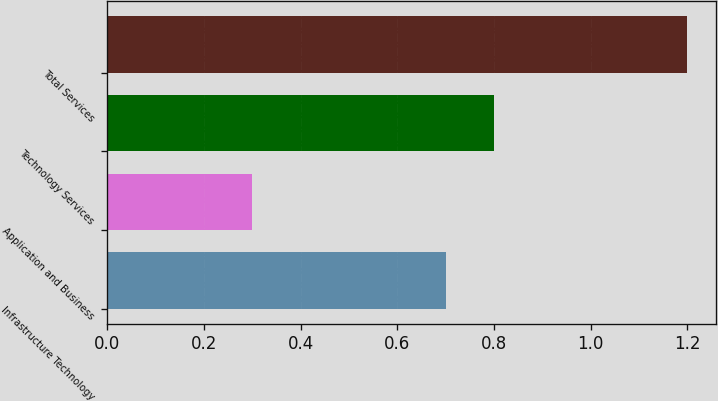Convert chart to OTSL. <chart><loc_0><loc_0><loc_500><loc_500><bar_chart><fcel>Infrastructure Technology<fcel>Application and Business<fcel>Technology Services<fcel>Total Services<nl><fcel>0.7<fcel>0.3<fcel>0.8<fcel>1.2<nl></chart> 